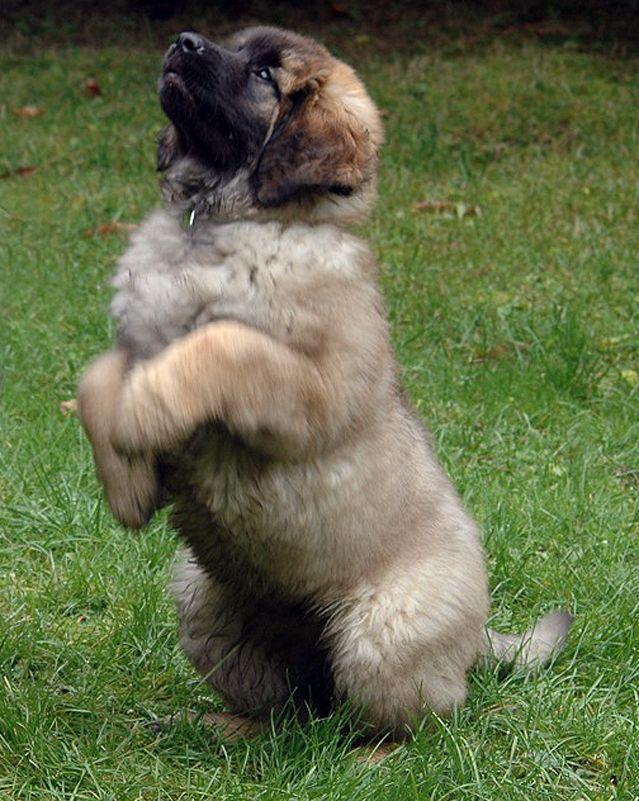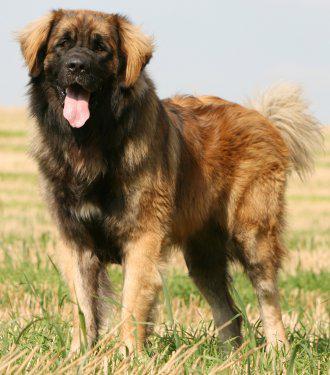The first image is the image on the left, the second image is the image on the right. For the images displayed, is the sentence "There are two dogs in the image on the right." factually correct? Answer yes or no. No. The first image is the image on the left, the second image is the image on the right. Given the left and right images, does the statement "One dog is positioned on the back of another dog." hold true? Answer yes or no. No. 